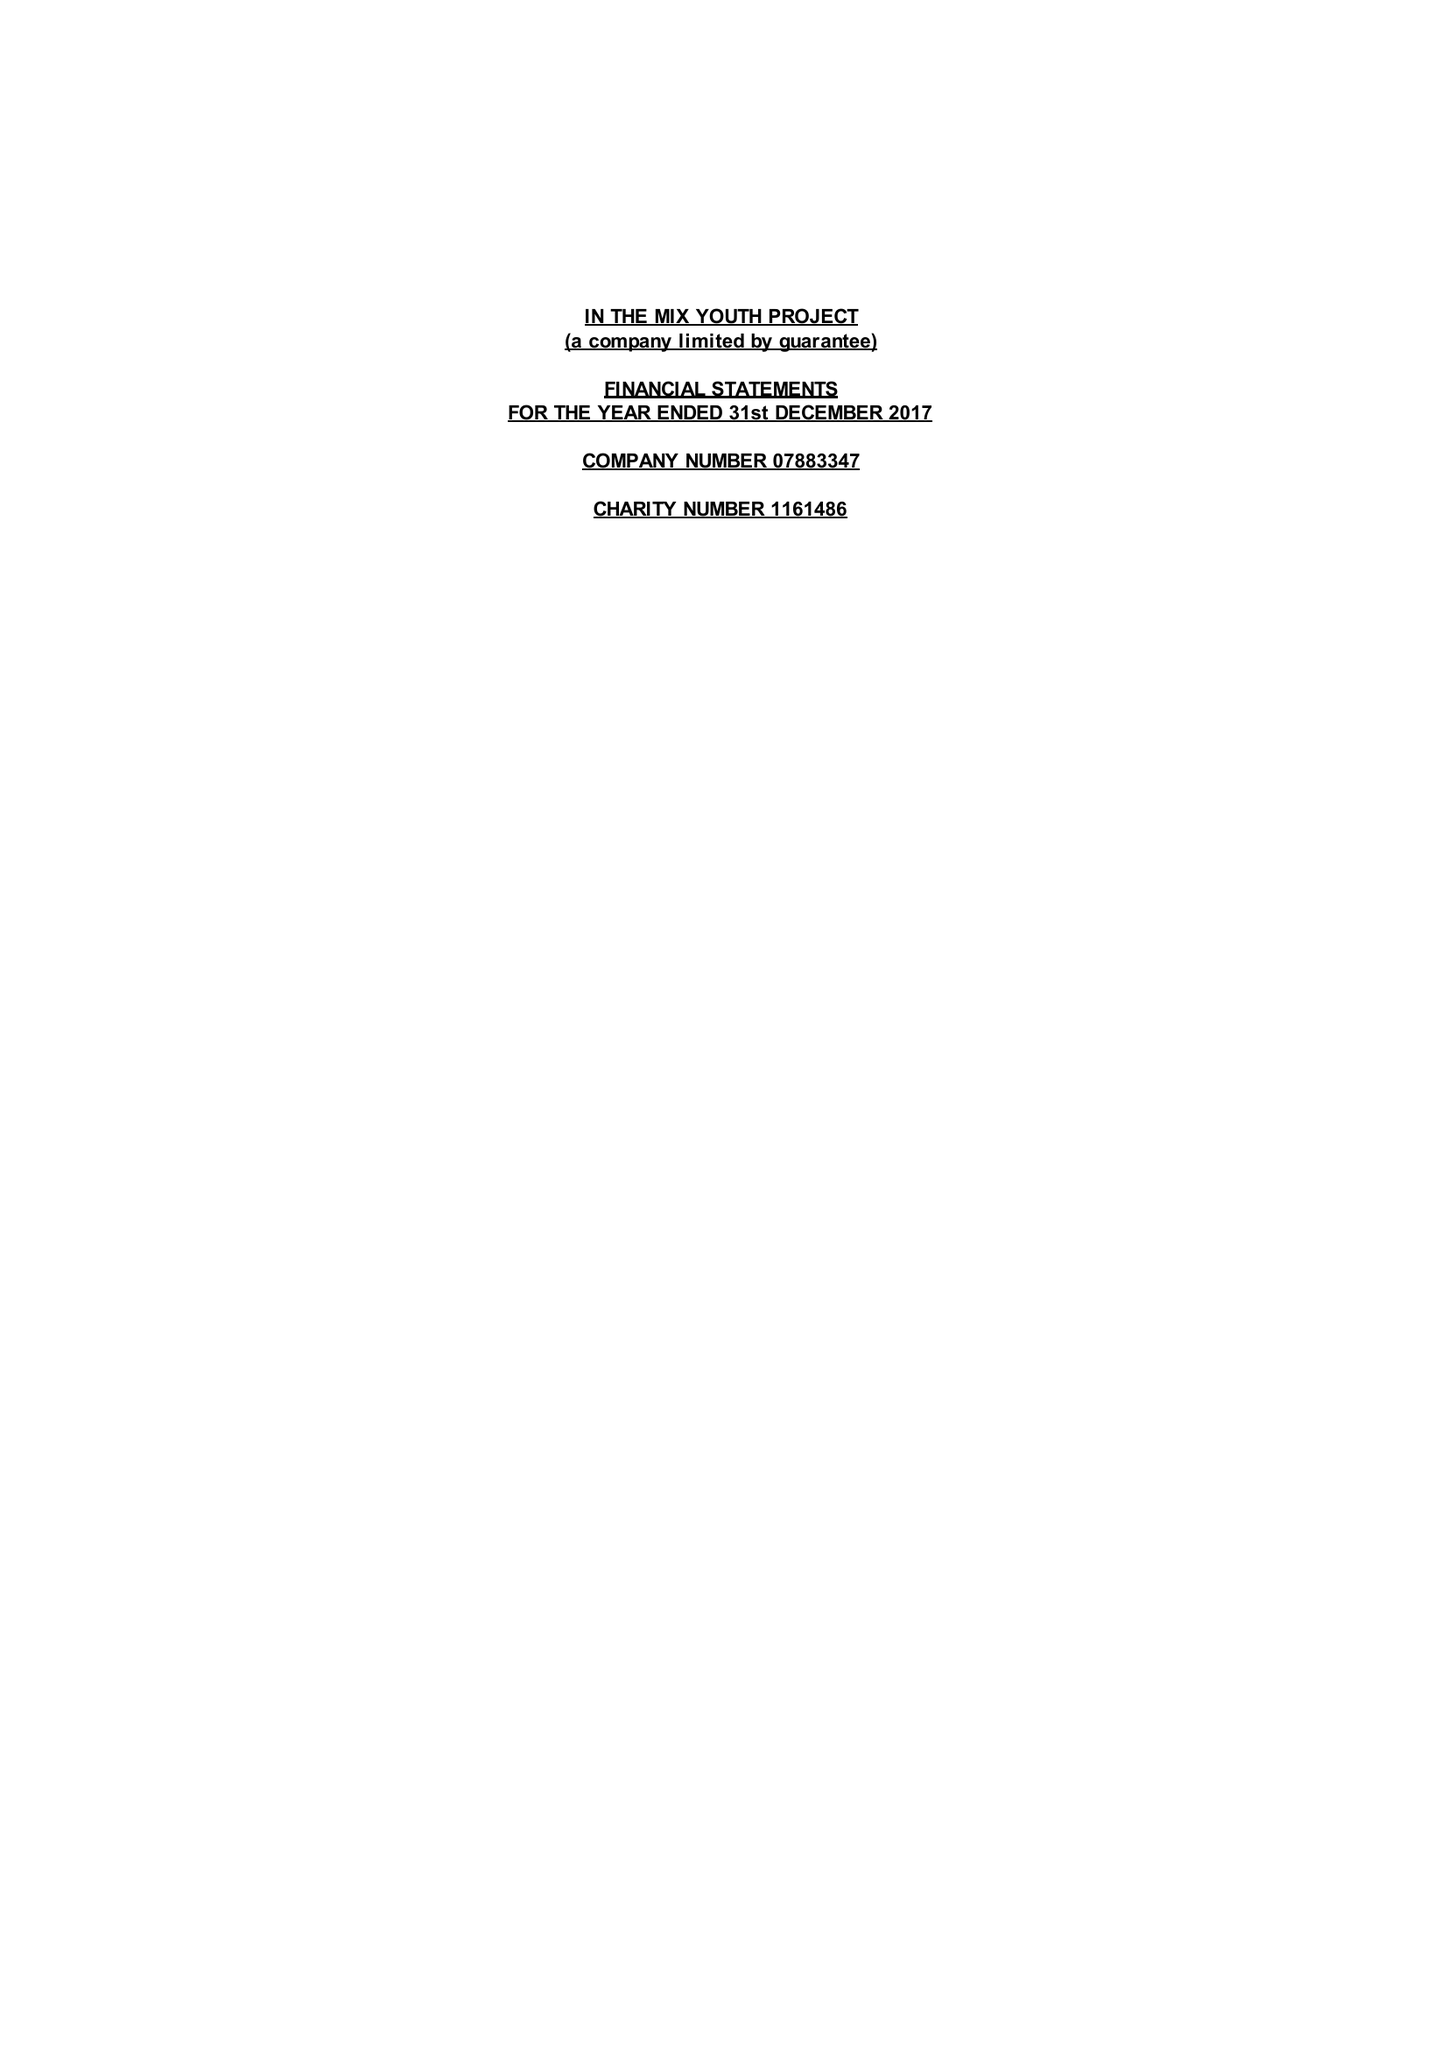What is the value for the address__postcode?
Answer the question using a single word or phrase. TA4 2NE 